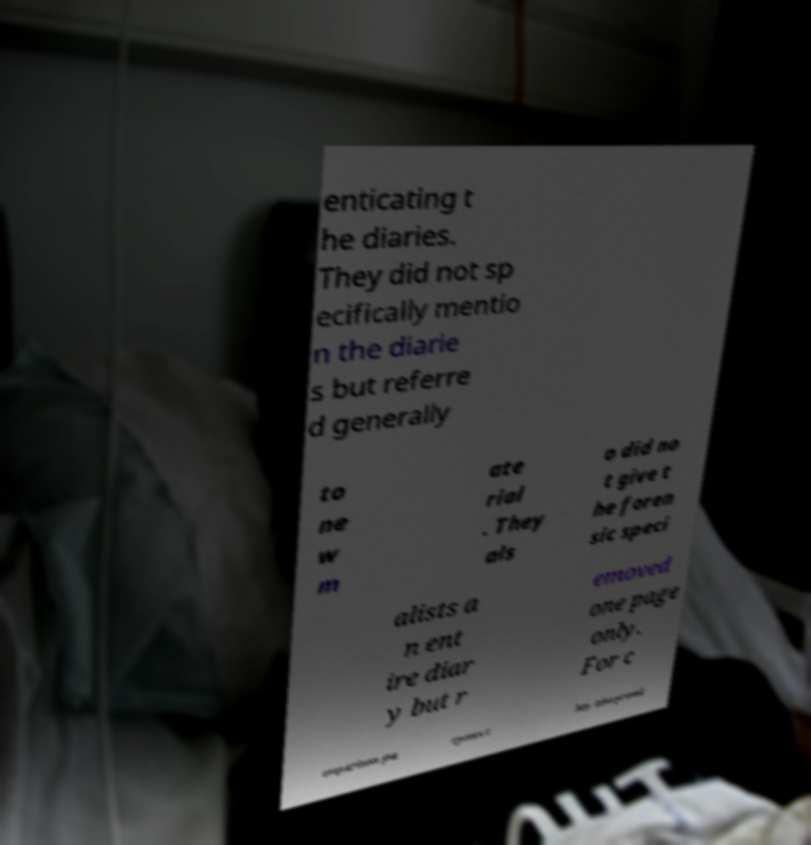Please identify and transcribe the text found in this image. enticating t he diaries. They did not sp ecifically mentio n the diarie s but referre d generally to ne w m ate rial . They als o did no t give t he foren sic speci alists a n ent ire diar y but r emoved one page only. For c omparison pu rposes t hey also provid 